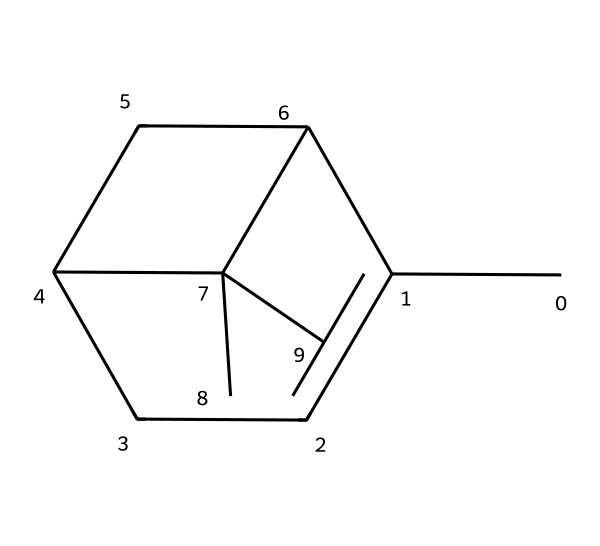What is the molecular formula of pinene? To find the molecular formula, we need to count the number of each type of atom in the SMILES representation. In this case, there are 10 carbon atoms and 16 hydrogen atoms. Therefore, the molecular formula is C10H16.
Answer: C10H16 How many rings are present in the structure of pinene? The structure can be analyzed to observe that pinene has two rings in its cycloalkane configuration. This can be visualized by identifying the closed loops in the structure.
Answer: 2 What type of compound is pinene classified as? Pinene is classified as a terpene, which is a type of hydrocarbon derived from plants, specifically known for being aromatic. This classification is based on its natural occurrence and structural characteristics.
Answer: terpene What is the IUPAC name of this compound? From the structure provided, we can deduce that the IUPAC name for this compound is alpha-pinene. This name is derived from its structural features and priority in naming conventions of terpenes.
Answer: alpha-pinene What is the total number of hydrogen atoms in pinene? To determine the total number of hydrogen atoms, simply count the hydrogen represented in the molecular formula derived earlier, which shows there are 16 hydrogen atoms.
Answer: 16 Which part of the chemical structure contributes to its pine scent? The specific arrangement of carbon and the double bonds in the cyclic structure of pinene contribute to the characteristic pine scent. This specific configuration is responsible for its aromatic properties.
Answer: cyclic structure 